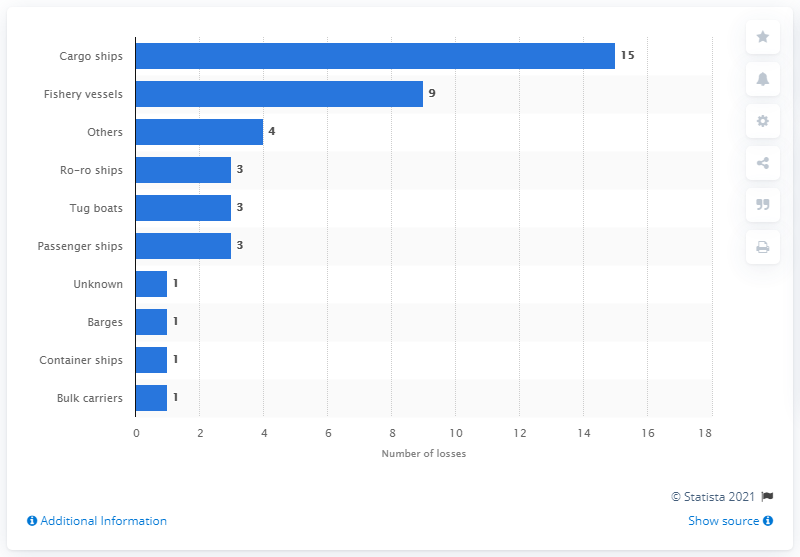Give some essential details in this illustration. There were 15 cargo ship losses in 2019. 